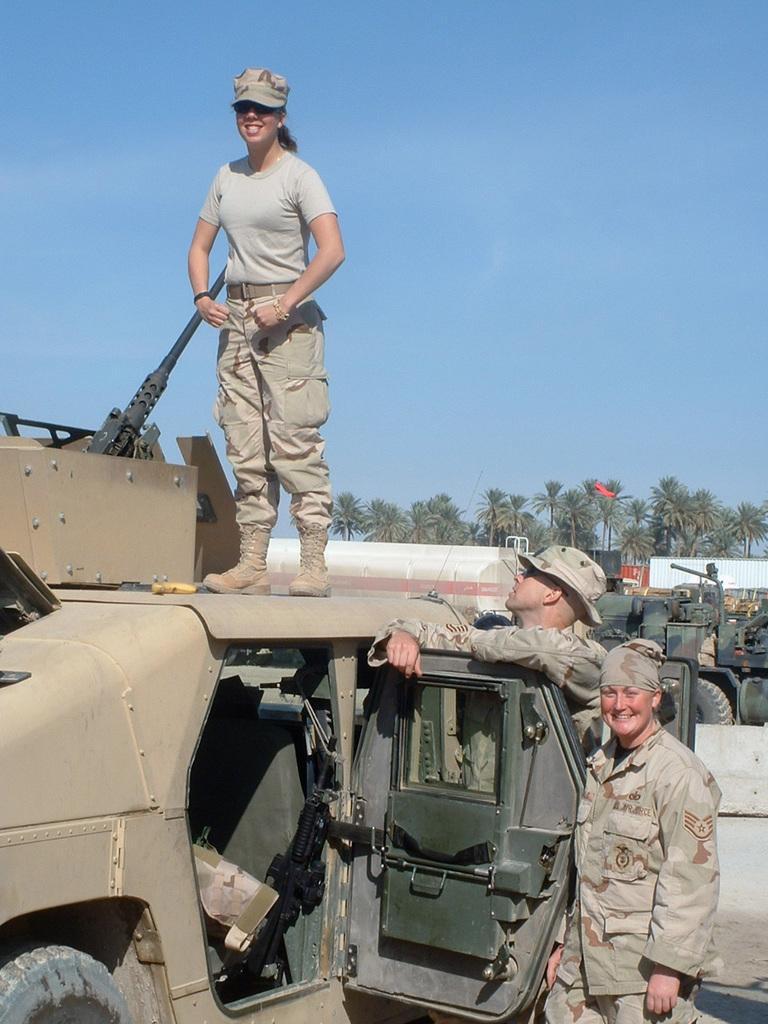In one or two sentences, can you explain what this image depicts? Bottom right side of the image two persons standing and smiling. Bottom left side of the image there is a vehicle, on the vehicle a woman is standing and smiling. Behind her there are some clouds and sky. Top right side of the image there are some trees. 